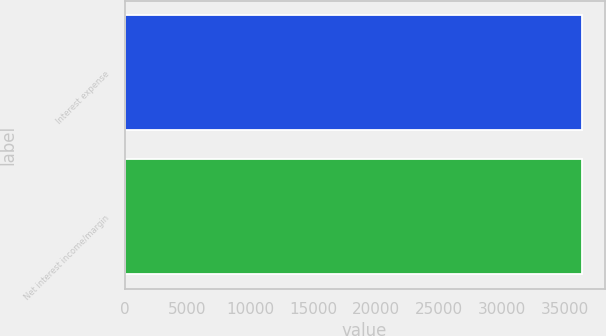Convert chart to OTSL. <chart><loc_0><loc_0><loc_500><loc_500><bar_chart><fcel>Interest expense<fcel>Net interest income/margin<nl><fcel>36368<fcel>36368.1<nl></chart> 